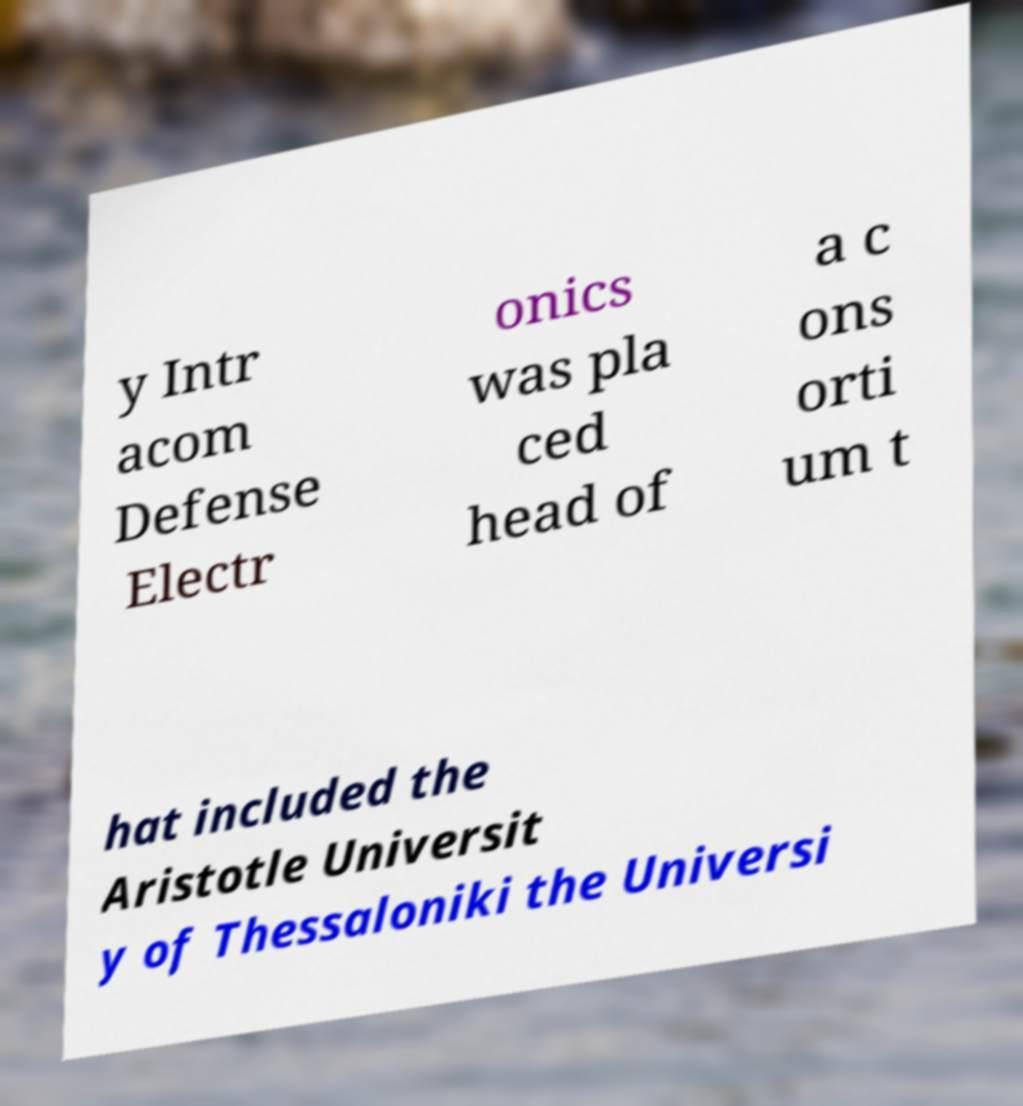Please read and relay the text visible in this image. What does it say? y Intr acom Defense Electr onics was pla ced head of a c ons orti um t hat included the Aristotle Universit y of Thessaloniki the Universi 